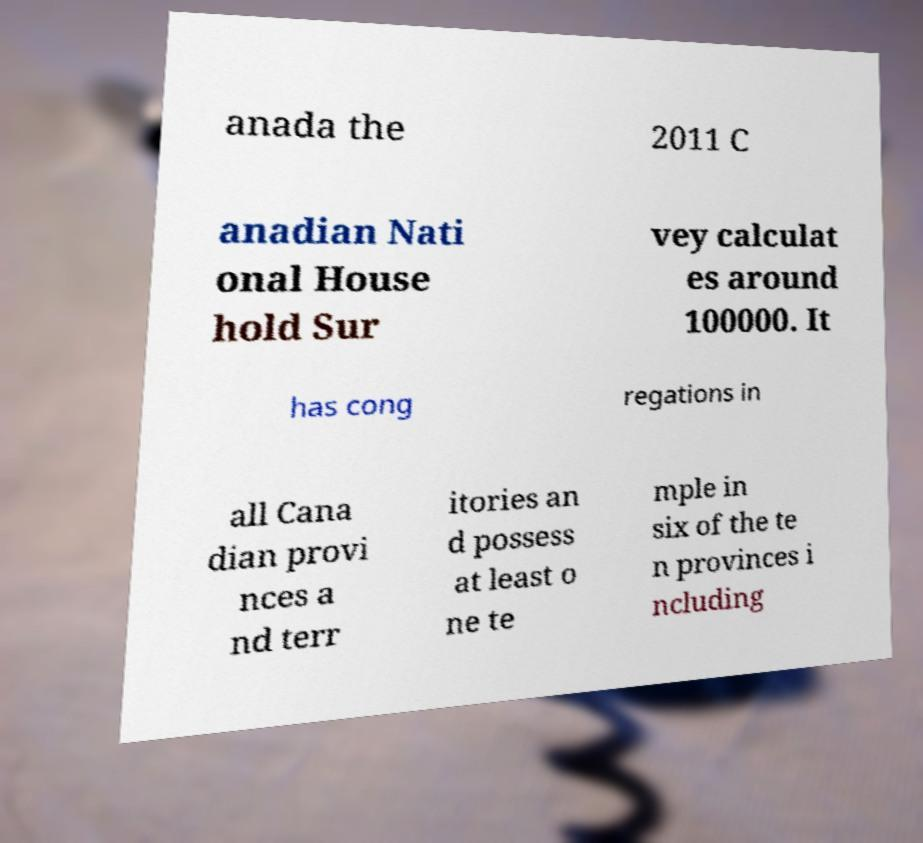Could you extract and type out the text from this image? anada the 2011 C anadian Nati onal House hold Sur vey calculat es around 100000. It has cong regations in all Cana dian provi nces a nd terr itories an d possess at least o ne te mple in six of the te n provinces i ncluding 